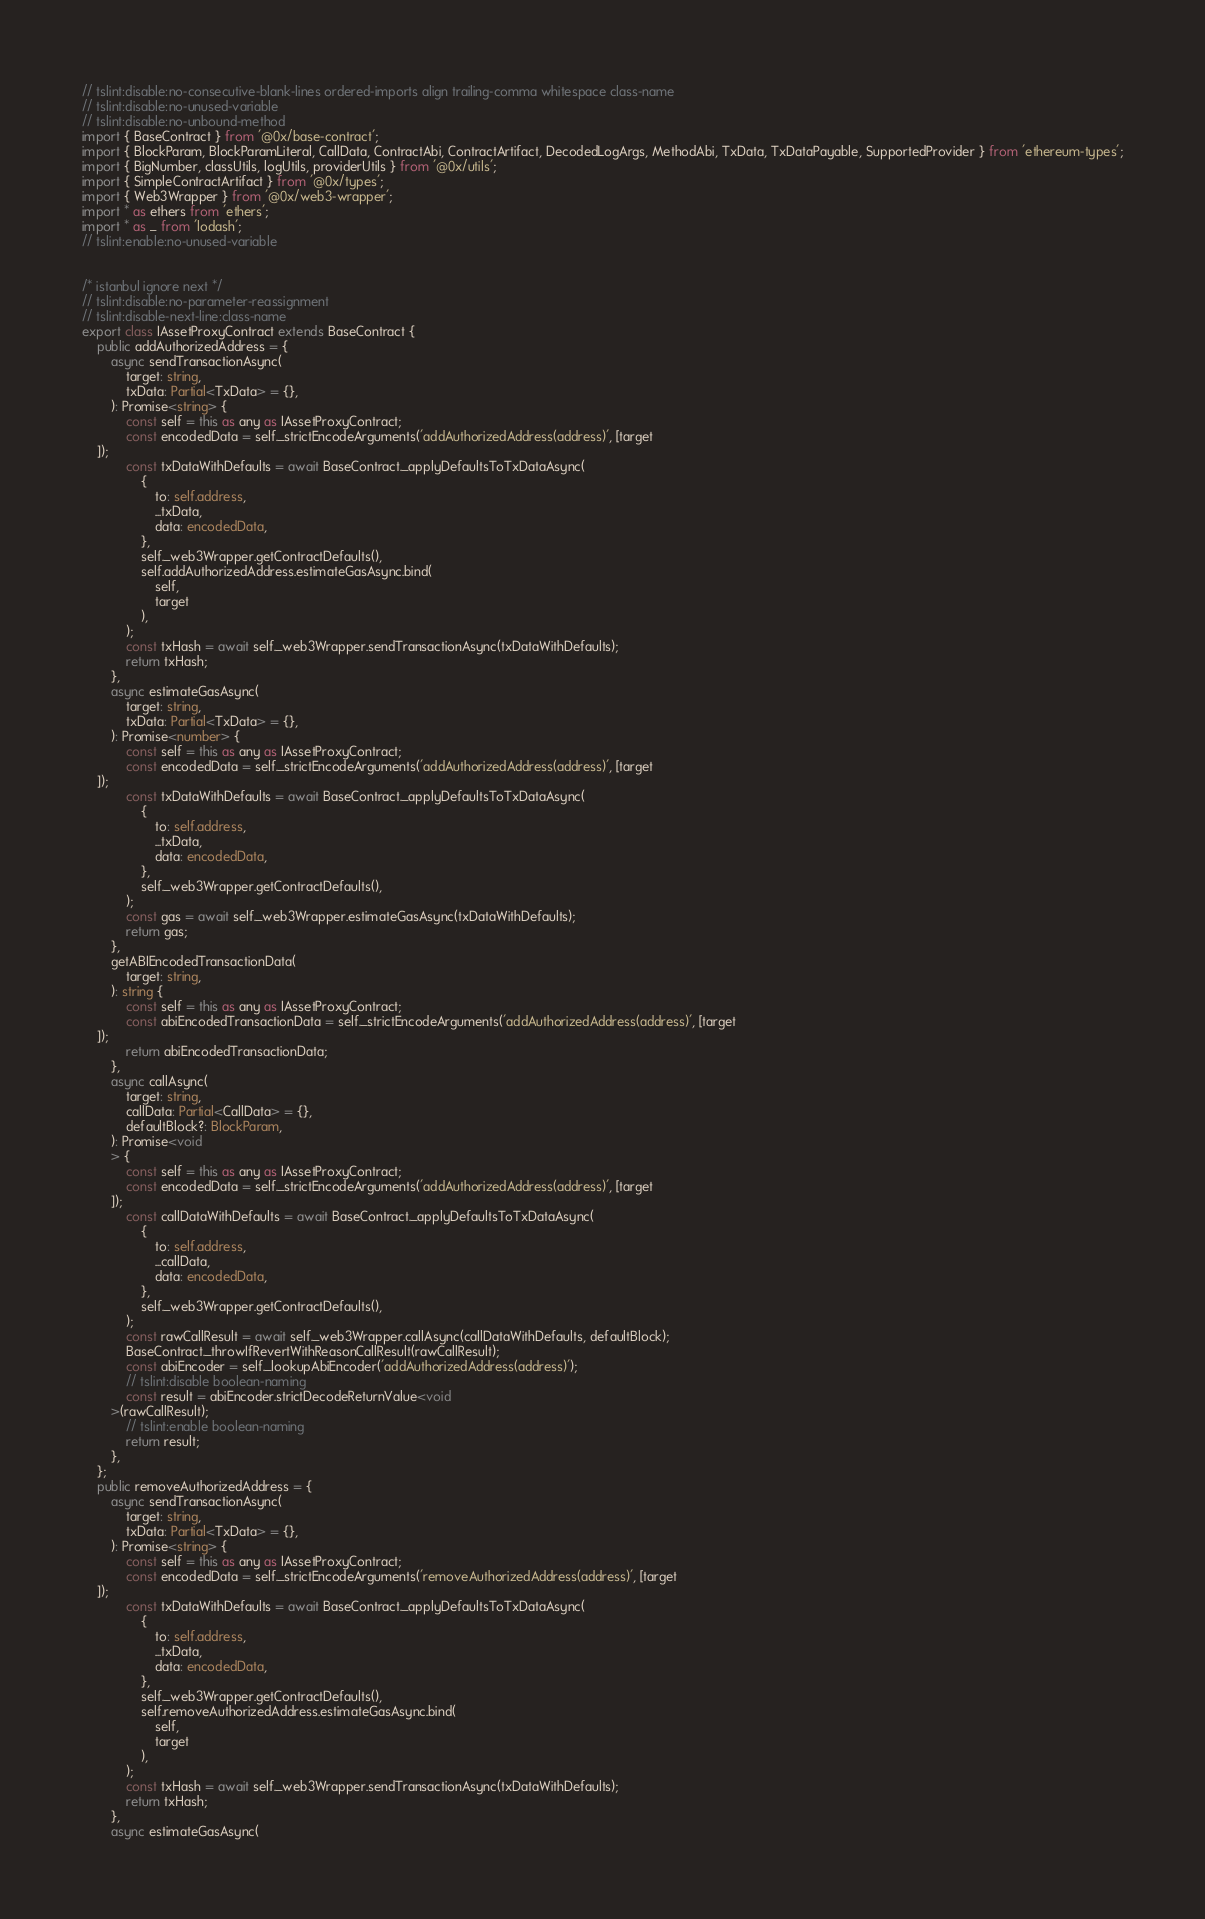Convert code to text. <code><loc_0><loc_0><loc_500><loc_500><_TypeScript_>// tslint:disable:no-consecutive-blank-lines ordered-imports align trailing-comma whitespace class-name
// tslint:disable:no-unused-variable
// tslint:disable:no-unbound-method
import { BaseContract } from '@0x/base-contract';
import { BlockParam, BlockParamLiteral, CallData, ContractAbi, ContractArtifact, DecodedLogArgs, MethodAbi, TxData, TxDataPayable, SupportedProvider } from 'ethereum-types';
import { BigNumber, classUtils, logUtils, providerUtils } from '@0x/utils';
import { SimpleContractArtifact } from '@0x/types';
import { Web3Wrapper } from '@0x/web3-wrapper';
import * as ethers from 'ethers';
import * as _ from 'lodash';
// tslint:enable:no-unused-variable


/* istanbul ignore next */
// tslint:disable:no-parameter-reassignment
// tslint:disable-next-line:class-name
export class IAssetProxyContract extends BaseContract {
    public addAuthorizedAddress = {
        async sendTransactionAsync(
            target: string,
            txData: Partial<TxData> = {},
        ): Promise<string> {
            const self = this as any as IAssetProxyContract;
            const encodedData = self._strictEncodeArguments('addAuthorizedAddress(address)', [target
    ]);
            const txDataWithDefaults = await BaseContract._applyDefaultsToTxDataAsync(
                {
                    to: self.address,
                    ...txData,
                    data: encodedData,
                },
                self._web3Wrapper.getContractDefaults(),
                self.addAuthorizedAddress.estimateGasAsync.bind(
                    self,
                    target
                ),
            );
            const txHash = await self._web3Wrapper.sendTransactionAsync(txDataWithDefaults);
            return txHash;
        },
        async estimateGasAsync(
            target: string,
            txData: Partial<TxData> = {},
        ): Promise<number> {
            const self = this as any as IAssetProxyContract;
            const encodedData = self._strictEncodeArguments('addAuthorizedAddress(address)', [target
    ]);
            const txDataWithDefaults = await BaseContract._applyDefaultsToTxDataAsync(
                {
                    to: self.address,
                    ...txData,
                    data: encodedData,
                },
                self._web3Wrapper.getContractDefaults(),
            );
            const gas = await self._web3Wrapper.estimateGasAsync(txDataWithDefaults);
            return gas;
        },
        getABIEncodedTransactionData(
            target: string,
        ): string {
            const self = this as any as IAssetProxyContract;
            const abiEncodedTransactionData = self._strictEncodeArguments('addAuthorizedAddress(address)', [target
    ]);
            return abiEncodedTransactionData;
        },
        async callAsync(
            target: string,
            callData: Partial<CallData> = {},
            defaultBlock?: BlockParam,
        ): Promise<void
        > {
            const self = this as any as IAssetProxyContract;
            const encodedData = self._strictEncodeArguments('addAuthorizedAddress(address)', [target
        ]);
            const callDataWithDefaults = await BaseContract._applyDefaultsToTxDataAsync(
                {
                    to: self.address,
                    ...callData,
                    data: encodedData,
                },
                self._web3Wrapper.getContractDefaults(),
            );
            const rawCallResult = await self._web3Wrapper.callAsync(callDataWithDefaults, defaultBlock);
            BaseContract._throwIfRevertWithReasonCallResult(rawCallResult);
            const abiEncoder = self._lookupAbiEncoder('addAuthorizedAddress(address)');
            // tslint:disable boolean-naming
            const result = abiEncoder.strictDecodeReturnValue<void
        >(rawCallResult);
            // tslint:enable boolean-naming
            return result;
        },
    };
    public removeAuthorizedAddress = {
        async sendTransactionAsync(
            target: string,
            txData: Partial<TxData> = {},
        ): Promise<string> {
            const self = this as any as IAssetProxyContract;
            const encodedData = self._strictEncodeArguments('removeAuthorizedAddress(address)', [target
    ]);
            const txDataWithDefaults = await BaseContract._applyDefaultsToTxDataAsync(
                {
                    to: self.address,
                    ...txData,
                    data: encodedData,
                },
                self._web3Wrapper.getContractDefaults(),
                self.removeAuthorizedAddress.estimateGasAsync.bind(
                    self,
                    target
                ),
            );
            const txHash = await self._web3Wrapper.sendTransactionAsync(txDataWithDefaults);
            return txHash;
        },
        async estimateGasAsync(</code> 